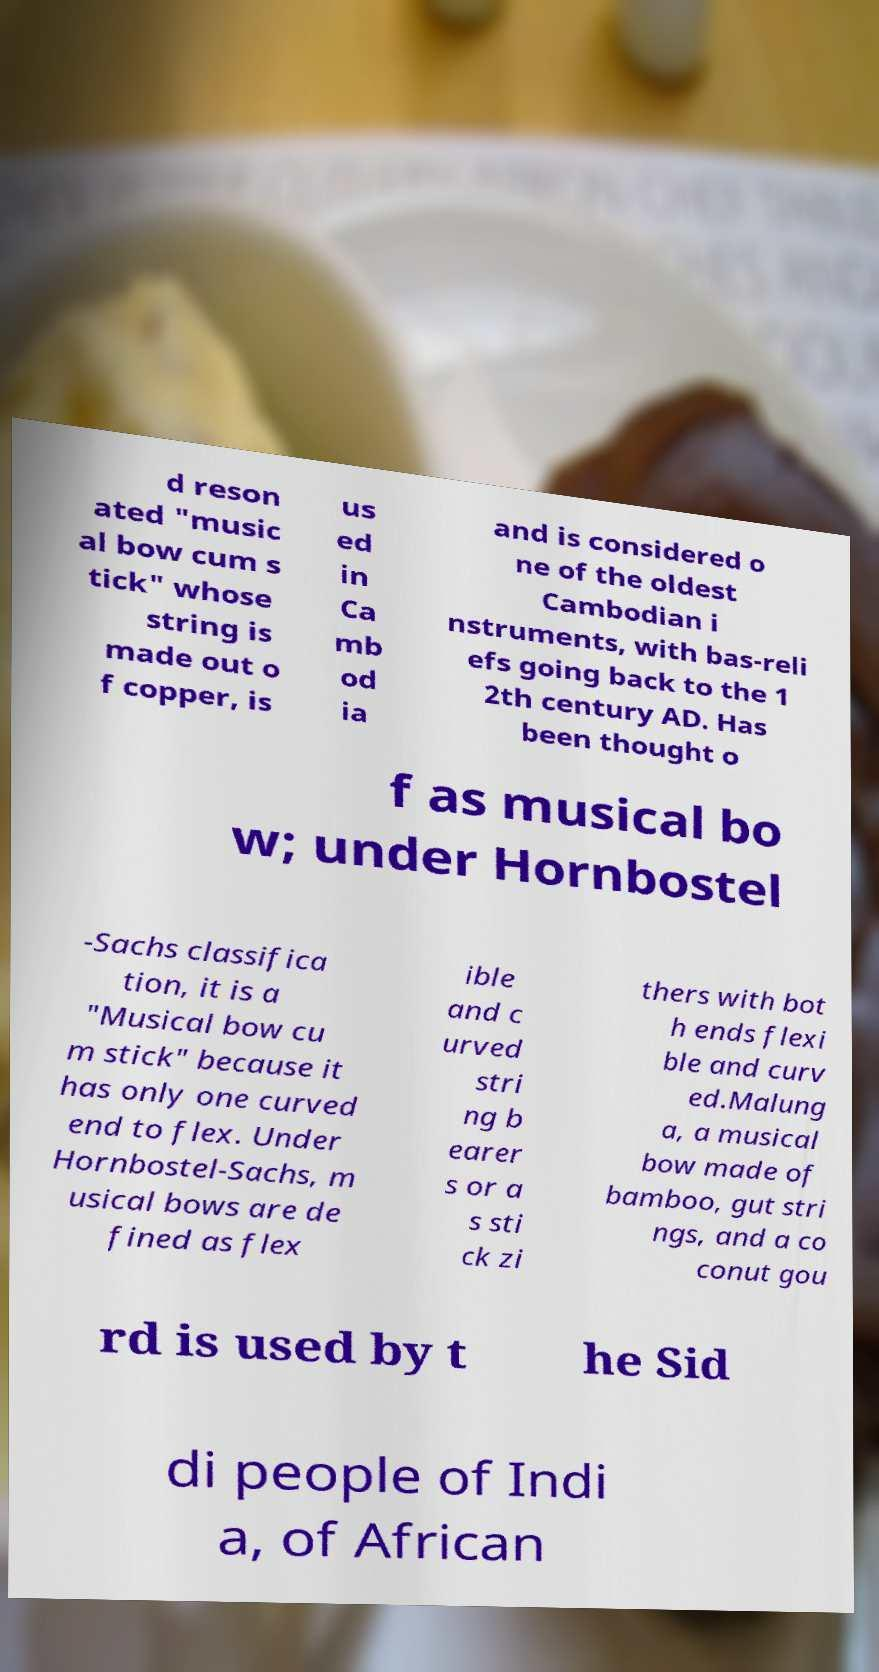Could you extract and type out the text from this image? d reson ated "music al bow cum s tick" whose string is made out o f copper, is us ed in Ca mb od ia and is considered o ne of the oldest Cambodian i nstruments, with bas-reli efs going back to the 1 2th century AD. Has been thought o f as musical bo w; under Hornbostel -Sachs classifica tion, it is a "Musical bow cu m stick" because it has only one curved end to flex. Under Hornbostel-Sachs, m usical bows are de fined as flex ible and c urved stri ng b earer s or a s sti ck zi thers with bot h ends flexi ble and curv ed.Malung a, a musical bow made of bamboo, gut stri ngs, and a co conut gou rd is used by t he Sid di people of Indi a, of African 